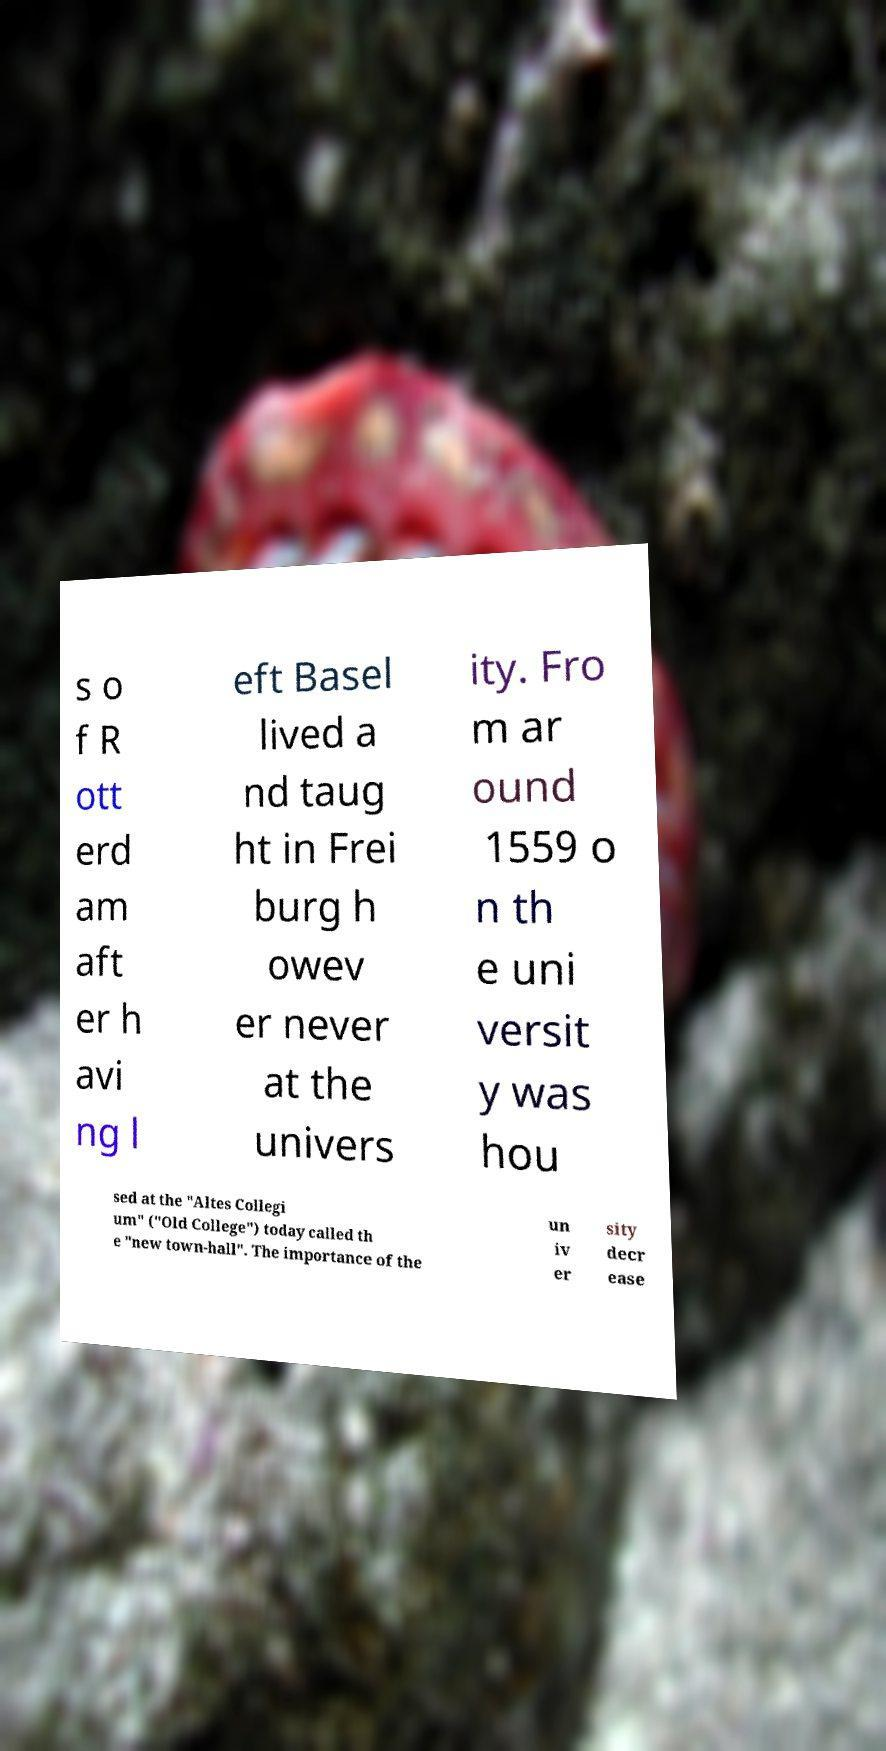Please read and relay the text visible in this image. What does it say? s o f R ott erd am aft er h avi ng l eft Basel lived a nd taug ht in Frei burg h owev er never at the univers ity. Fro m ar ound 1559 o n th e uni versit y was hou sed at the "Altes Collegi um" ("Old College") today called th e "new town-hall". The importance of the un iv er sity decr ease 